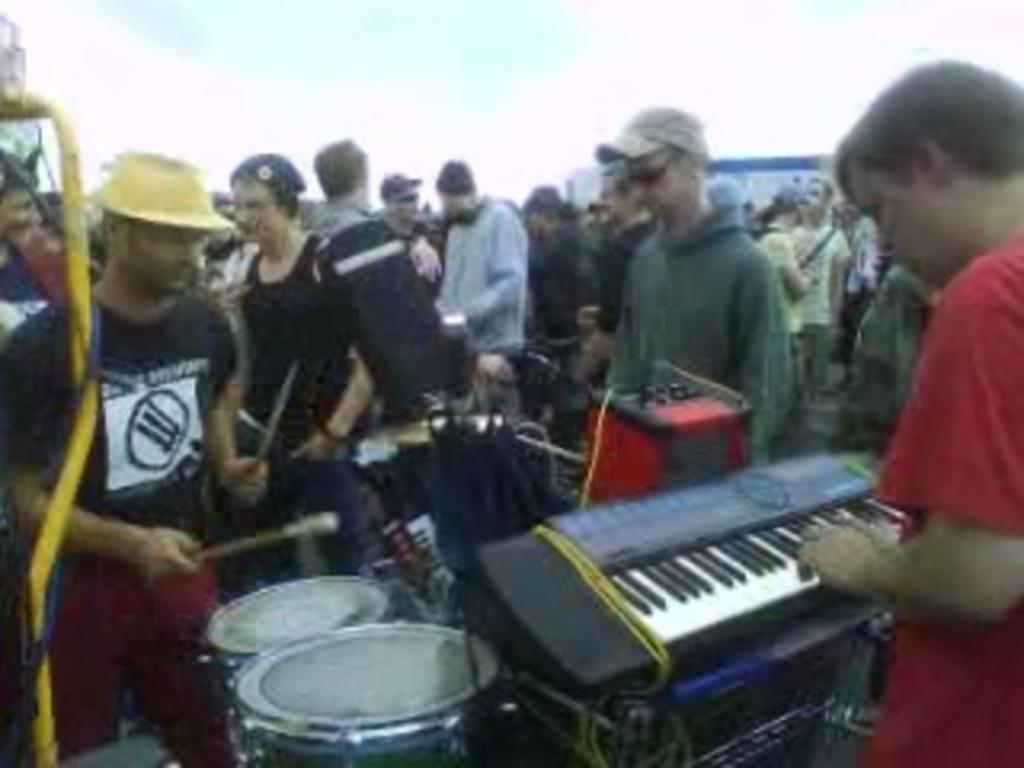What event is taking place in the image? There is a musical festival in the image. Can you describe the people in the image? There are people in the image, including one person playing the keyboard and another person beating the drums. Where is the cactus located in the image? There is no cactus present in the image. What type of adjustment is being made to the drum set in the image? There is no adjustment being made to the drum set in the image; the person is simply playing the drums. 